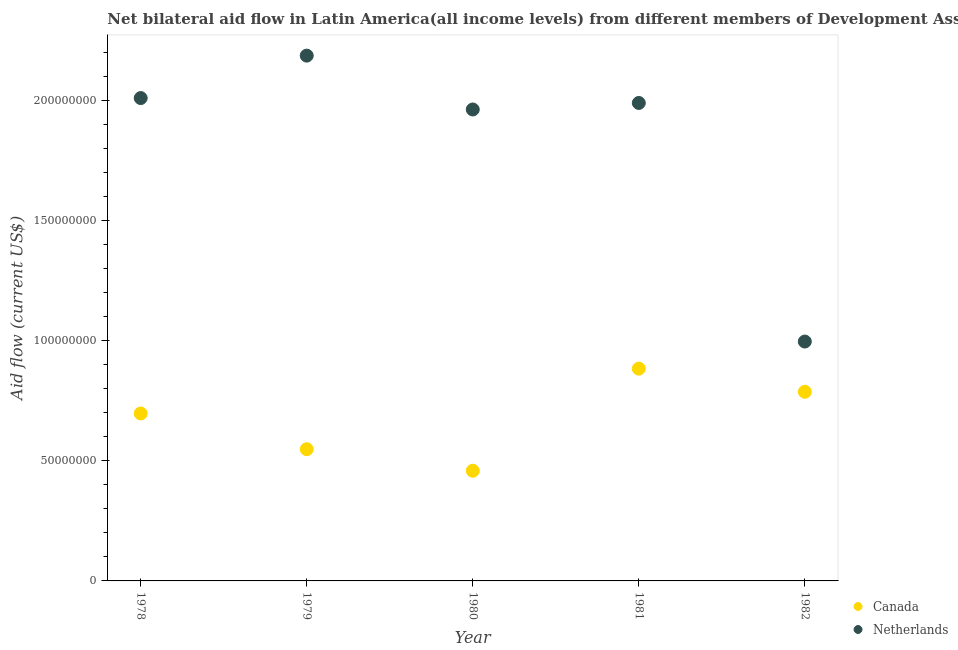How many different coloured dotlines are there?
Offer a terse response. 2. What is the amount of aid given by netherlands in 1982?
Provide a succinct answer. 9.96e+07. Across all years, what is the maximum amount of aid given by netherlands?
Make the answer very short. 2.19e+08. Across all years, what is the minimum amount of aid given by netherlands?
Provide a short and direct response. 9.96e+07. In which year was the amount of aid given by canada maximum?
Provide a succinct answer. 1981. In which year was the amount of aid given by canada minimum?
Your answer should be very brief. 1980. What is the total amount of aid given by netherlands in the graph?
Ensure brevity in your answer.  9.14e+08. What is the difference between the amount of aid given by netherlands in 1979 and that in 1982?
Give a very brief answer. 1.19e+08. What is the difference between the amount of aid given by netherlands in 1982 and the amount of aid given by canada in 1978?
Give a very brief answer. 2.99e+07. What is the average amount of aid given by canada per year?
Ensure brevity in your answer.  6.75e+07. In the year 1978, what is the difference between the amount of aid given by netherlands and amount of aid given by canada?
Give a very brief answer. 1.31e+08. In how many years, is the amount of aid given by netherlands greater than 180000000 US$?
Make the answer very short. 4. What is the ratio of the amount of aid given by canada in 1978 to that in 1982?
Offer a very short reply. 0.89. Is the amount of aid given by netherlands in 1981 less than that in 1982?
Provide a short and direct response. No. Is the difference between the amount of aid given by netherlands in 1980 and 1981 greater than the difference between the amount of aid given by canada in 1980 and 1981?
Offer a very short reply. Yes. What is the difference between the highest and the second highest amount of aid given by canada?
Your answer should be compact. 9.62e+06. What is the difference between the highest and the lowest amount of aid given by netherlands?
Give a very brief answer. 1.19e+08. In how many years, is the amount of aid given by netherlands greater than the average amount of aid given by netherlands taken over all years?
Provide a short and direct response. 4. Is the sum of the amount of aid given by canada in 1978 and 1980 greater than the maximum amount of aid given by netherlands across all years?
Your response must be concise. No. Does the amount of aid given by canada monotonically increase over the years?
Ensure brevity in your answer.  No. Is the amount of aid given by canada strictly less than the amount of aid given by netherlands over the years?
Make the answer very short. Yes. How many years are there in the graph?
Provide a succinct answer. 5. What is the difference between two consecutive major ticks on the Y-axis?
Your answer should be compact. 5.00e+07. Does the graph contain any zero values?
Offer a very short reply. No. Where does the legend appear in the graph?
Your answer should be compact. Bottom right. How many legend labels are there?
Offer a very short reply. 2. What is the title of the graph?
Offer a very short reply. Net bilateral aid flow in Latin America(all income levels) from different members of Development Assistance Committee. Does "Quality of trade" appear as one of the legend labels in the graph?
Provide a short and direct response. No. What is the Aid flow (current US$) in Canada in 1978?
Provide a succinct answer. 6.97e+07. What is the Aid flow (current US$) of Netherlands in 1978?
Offer a very short reply. 2.01e+08. What is the Aid flow (current US$) in Canada in 1979?
Your response must be concise. 5.48e+07. What is the Aid flow (current US$) of Netherlands in 1979?
Ensure brevity in your answer.  2.19e+08. What is the Aid flow (current US$) of Canada in 1980?
Offer a terse response. 4.58e+07. What is the Aid flow (current US$) in Netherlands in 1980?
Provide a short and direct response. 1.96e+08. What is the Aid flow (current US$) in Canada in 1981?
Your response must be concise. 8.83e+07. What is the Aid flow (current US$) in Netherlands in 1981?
Your answer should be compact. 1.99e+08. What is the Aid flow (current US$) in Canada in 1982?
Offer a terse response. 7.87e+07. What is the Aid flow (current US$) of Netherlands in 1982?
Make the answer very short. 9.96e+07. Across all years, what is the maximum Aid flow (current US$) of Canada?
Offer a very short reply. 8.83e+07. Across all years, what is the maximum Aid flow (current US$) of Netherlands?
Your answer should be compact. 2.19e+08. Across all years, what is the minimum Aid flow (current US$) of Canada?
Make the answer very short. 4.58e+07. Across all years, what is the minimum Aid flow (current US$) of Netherlands?
Your response must be concise. 9.96e+07. What is the total Aid flow (current US$) of Canada in the graph?
Provide a succinct answer. 3.37e+08. What is the total Aid flow (current US$) of Netherlands in the graph?
Offer a terse response. 9.14e+08. What is the difference between the Aid flow (current US$) of Canada in 1978 and that in 1979?
Your answer should be compact. 1.49e+07. What is the difference between the Aid flow (current US$) in Netherlands in 1978 and that in 1979?
Provide a succinct answer. -1.76e+07. What is the difference between the Aid flow (current US$) of Canada in 1978 and that in 1980?
Offer a very short reply. 2.38e+07. What is the difference between the Aid flow (current US$) in Netherlands in 1978 and that in 1980?
Your answer should be compact. 4.75e+06. What is the difference between the Aid flow (current US$) of Canada in 1978 and that in 1981?
Your answer should be very brief. -1.86e+07. What is the difference between the Aid flow (current US$) of Netherlands in 1978 and that in 1981?
Your answer should be compact. 2.04e+06. What is the difference between the Aid flow (current US$) of Canada in 1978 and that in 1982?
Provide a short and direct response. -9.03e+06. What is the difference between the Aid flow (current US$) in Netherlands in 1978 and that in 1982?
Provide a succinct answer. 1.01e+08. What is the difference between the Aid flow (current US$) in Canada in 1979 and that in 1980?
Your response must be concise. 8.97e+06. What is the difference between the Aid flow (current US$) of Netherlands in 1979 and that in 1980?
Provide a short and direct response. 2.24e+07. What is the difference between the Aid flow (current US$) of Canada in 1979 and that in 1981?
Provide a short and direct response. -3.35e+07. What is the difference between the Aid flow (current US$) in Netherlands in 1979 and that in 1981?
Provide a succinct answer. 1.97e+07. What is the difference between the Aid flow (current US$) of Canada in 1979 and that in 1982?
Your response must be concise. -2.39e+07. What is the difference between the Aid flow (current US$) of Netherlands in 1979 and that in 1982?
Your answer should be compact. 1.19e+08. What is the difference between the Aid flow (current US$) of Canada in 1980 and that in 1981?
Offer a terse response. -4.25e+07. What is the difference between the Aid flow (current US$) in Netherlands in 1980 and that in 1981?
Your answer should be compact. -2.71e+06. What is the difference between the Aid flow (current US$) in Canada in 1980 and that in 1982?
Keep it short and to the point. -3.29e+07. What is the difference between the Aid flow (current US$) in Netherlands in 1980 and that in 1982?
Offer a very short reply. 9.65e+07. What is the difference between the Aid flow (current US$) of Canada in 1981 and that in 1982?
Ensure brevity in your answer.  9.62e+06. What is the difference between the Aid flow (current US$) in Netherlands in 1981 and that in 1982?
Give a very brief answer. 9.92e+07. What is the difference between the Aid flow (current US$) in Canada in 1978 and the Aid flow (current US$) in Netherlands in 1979?
Your response must be concise. -1.49e+08. What is the difference between the Aid flow (current US$) of Canada in 1978 and the Aid flow (current US$) of Netherlands in 1980?
Your response must be concise. -1.26e+08. What is the difference between the Aid flow (current US$) in Canada in 1978 and the Aid flow (current US$) in Netherlands in 1981?
Offer a very short reply. -1.29e+08. What is the difference between the Aid flow (current US$) of Canada in 1978 and the Aid flow (current US$) of Netherlands in 1982?
Provide a succinct answer. -2.99e+07. What is the difference between the Aid flow (current US$) in Canada in 1979 and the Aid flow (current US$) in Netherlands in 1980?
Provide a succinct answer. -1.41e+08. What is the difference between the Aid flow (current US$) of Canada in 1979 and the Aid flow (current US$) of Netherlands in 1981?
Give a very brief answer. -1.44e+08. What is the difference between the Aid flow (current US$) of Canada in 1979 and the Aid flow (current US$) of Netherlands in 1982?
Offer a terse response. -4.48e+07. What is the difference between the Aid flow (current US$) in Canada in 1980 and the Aid flow (current US$) in Netherlands in 1981?
Keep it short and to the point. -1.53e+08. What is the difference between the Aid flow (current US$) in Canada in 1980 and the Aid flow (current US$) in Netherlands in 1982?
Ensure brevity in your answer.  -5.38e+07. What is the difference between the Aid flow (current US$) in Canada in 1981 and the Aid flow (current US$) in Netherlands in 1982?
Provide a short and direct response. -1.13e+07. What is the average Aid flow (current US$) in Canada per year?
Give a very brief answer. 6.75e+07. What is the average Aid flow (current US$) of Netherlands per year?
Offer a terse response. 1.83e+08. In the year 1978, what is the difference between the Aid flow (current US$) in Canada and Aid flow (current US$) in Netherlands?
Your response must be concise. -1.31e+08. In the year 1979, what is the difference between the Aid flow (current US$) in Canada and Aid flow (current US$) in Netherlands?
Make the answer very short. -1.64e+08. In the year 1980, what is the difference between the Aid flow (current US$) of Canada and Aid flow (current US$) of Netherlands?
Keep it short and to the point. -1.50e+08. In the year 1981, what is the difference between the Aid flow (current US$) in Canada and Aid flow (current US$) in Netherlands?
Your answer should be very brief. -1.11e+08. In the year 1982, what is the difference between the Aid flow (current US$) of Canada and Aid flow (current US$) of Netherlands?
Offer a very short reply. -2.09e+07. What is the ratio of the Aid flow (current US$) in Canada in 1978 to that in 1979?
Provide a short and direct response. 1.27. What is the ratio of the Aid flow (current US$) in Netherlands in 1978 to that in 1979?
Your answer should be compact. 0.92. What is the ratio of the Aid flow (current US$) in Canada in 1978 to that in 1980?
Your answer should be very brief. 1.52. What is the ratio of the Aid flow (current US$) of Netherlands in 1978 to that in 1980?
Offer a terse response. 1.02. What is the ratio of the Aid flow (current US$) of Canada in 1978 to that in 1981?
Your answer should be very brief. 0.79. What is the ratio of the Aid flow (current US$) in Netherlands in 1978 to that in 1981?
Your answer should be compact. 1.01. What is the ratio of the Aid flow (current US$) in Canada in 1978 to that in 1982?
Give a very brief answer. 0.89. What is the ratio of the Aid flow (current US$) of Netherlands in 1978 to that in 1982?
Give a very brief answer. 2.02. What is the ratio of the Aid flow (current US$) in Canada in 1979 to that in 1980?
Offer a very short reply. 1.2. What is the ratio of the Aid flow (current US$) in Netherlands in 1979 to that in 1980?
Make the answer very short. 1.11. What is the ratio of the Aid flow (current US$) in Canada in 1979 to that in 1981?
Provide a short and direct response. 0.62. What is the ratio of the Aid flow (current US$) in Netherlands in 1979 to that in 1981?
Give a very brief answer. 1.1. What is the ratio of the Aid flow (current US$) in Canada in 1979 to that in 1982?
Your answer should be very brief. 0.7. What is the ratio of the Aid flow (current US$) of Netherlands in 1979 to that in 1982?
Make the answer very short. 2.19. What is the ratio of the Aid flow (current US$) in Canada in 1980 to that in 1981?
Ensure brevity in your answer.  0.52. What is the ratio of the Aid flow (current US$) of Netherlands in 1980 to that in 1981?
Offer a terse response. 0.99. What is the ratio of the Aid flow (current US$) of Canada in 1980 to that in 1982?
Offer a terse response. 0.58. What is the ratio of the Aid flow (current US$) of Netherlands in 1980 to that in 1982?
Provide a succinct answer. 1.97. What is the ratio of the Aid flow (current US$) of Canada in 1981 to that in 1982?
Give a very brief answer. 1.12. What is the ratio of the Aid flow (current US$) of Netherlands in 1981 to that in 1982?
Offer a very short reply. 2. What is the difference between the highest and the second highest Aid flow (current US$) of Canada?
Provide a short and direct response. 9.62e+06. What is the difference between the highest and the second highest Aid flow (current US$) in Netherlands?
Provide a succinct answer. 1.76e+07. What is the difference between the highest and the lowest Aid flow (current US$) in Canada?
Your answer should be compact. 4.25e+07. What is the difference between the highest and the lowest Aid flow (current US$) of Netherlands?
Provide a succinct answer. 1.19e+08. 